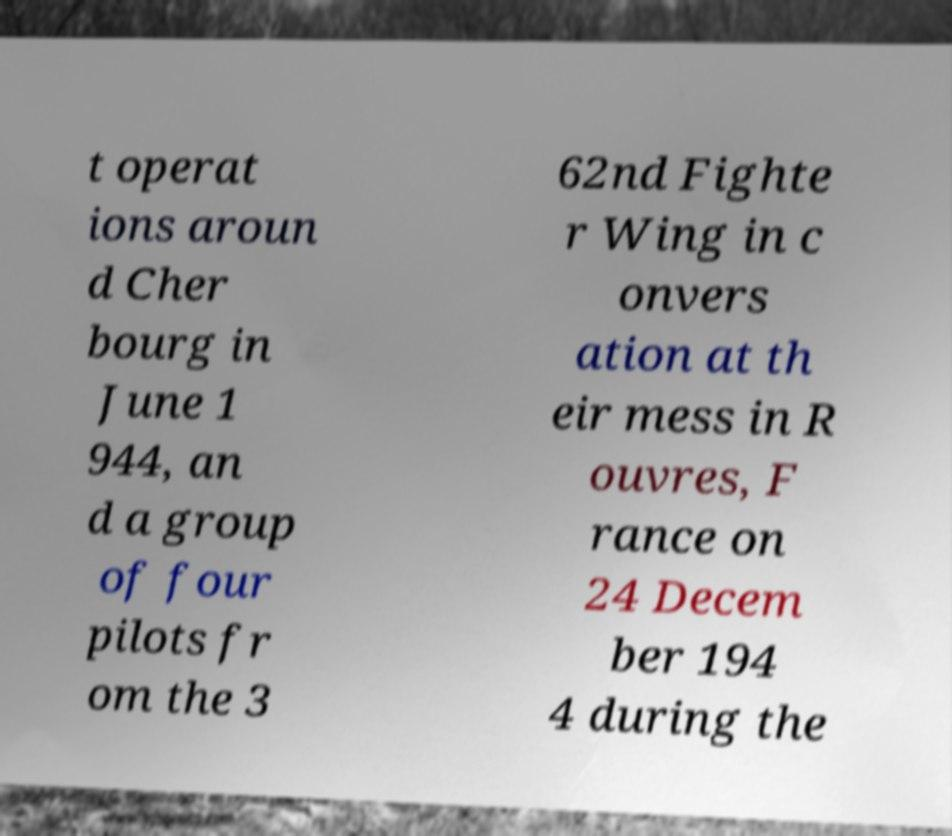There's text embedded in this image that I need extracted. Can you transcribe it verbatim? t operat ions aroun d Cher bourg in June 1 944, an d a group of four pilots fr om the 3 62nd Fighte r Wing in c onvers ation at th eir mess in R ouvres, F rance on 24 Decem ber 194 4 during the 